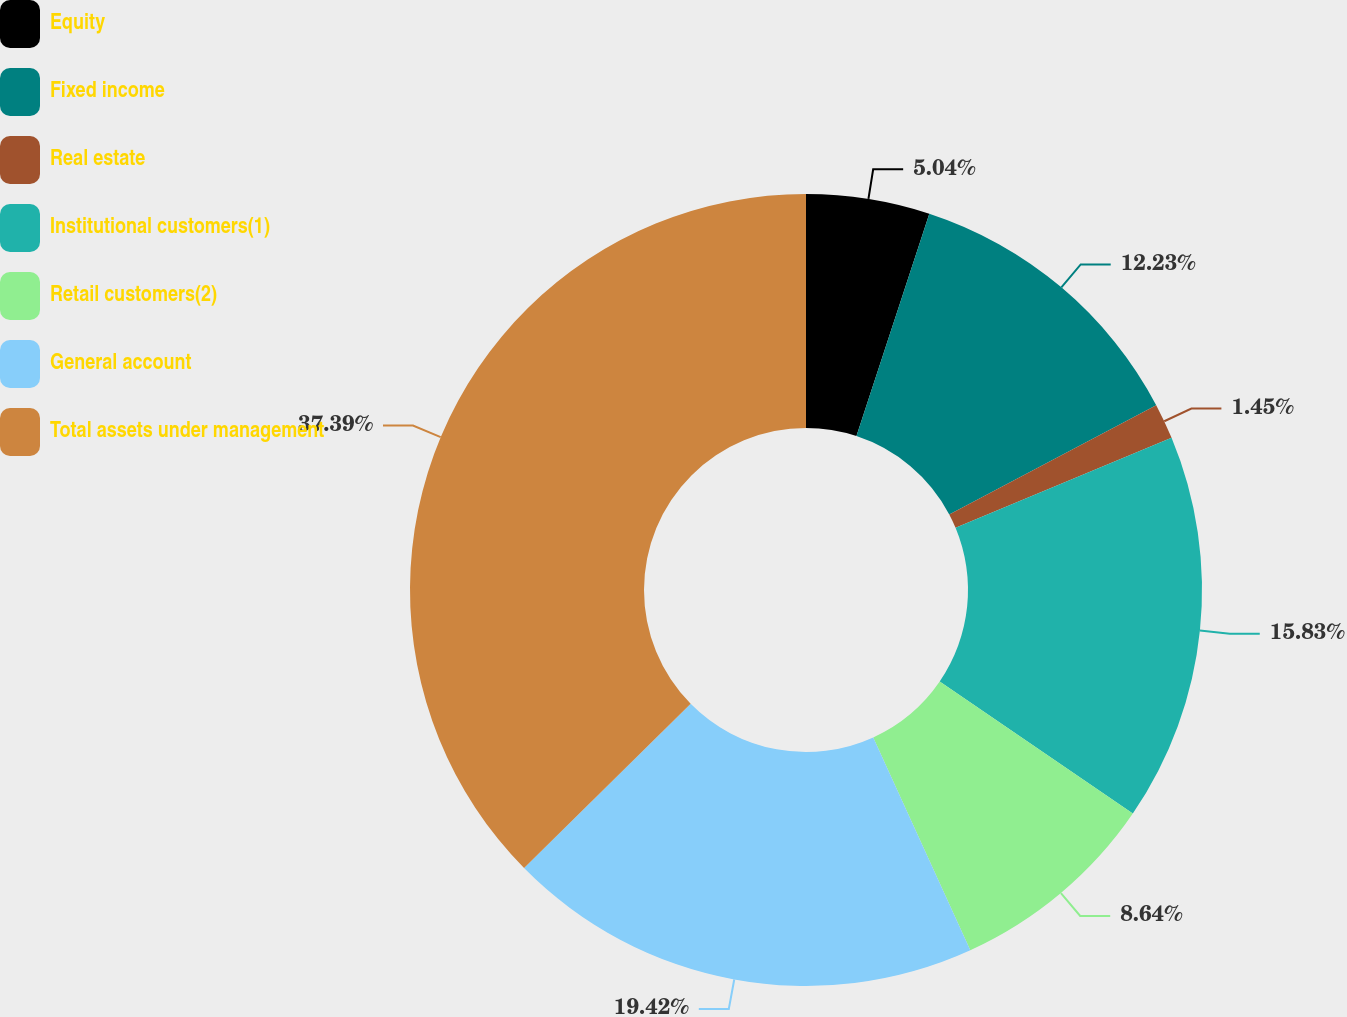Convert chart to OTSL. <chart><loc_0><loc_0><loc_500><loc_500><pie_chart><fcel>Equity<fcel>Fixed income<fcel>Real estate<fcel>Institutional customers(1)<fcel>Retail customers(2)<fcel>General account<fcel>Total assets under management<nl><fcel>5.04%<fcel>12.23%<fcel>1.45%<fcel>15.83%<fcel>8.64%<fcel>19.42%<fcel>37.39%<nl></chart> 